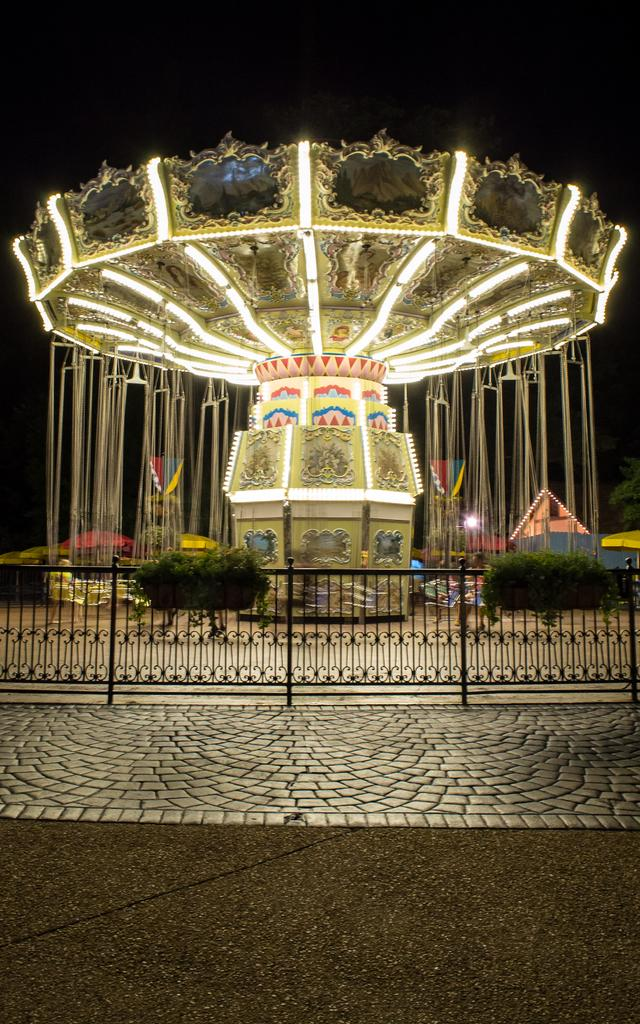What is the main subject in the center of the image? There is a fun ride in the center of the image. How is the fun ride decorated? The fun ride is decorated with lights. Can you describe the girl at the bottom of the image? There is a girl at the bottom of the image. What else can be seen in the image besides the fun ride and the girl? There is a road visible in the image. How many snakes are wrapped around the fun ride in the image? There are no snakes present in the image; the fun ride is decorated with lights. Why is the girl at the bottom of the image crying? There is no indication in the image that the girl is crying; she is simply standing at the bottom of the image. 